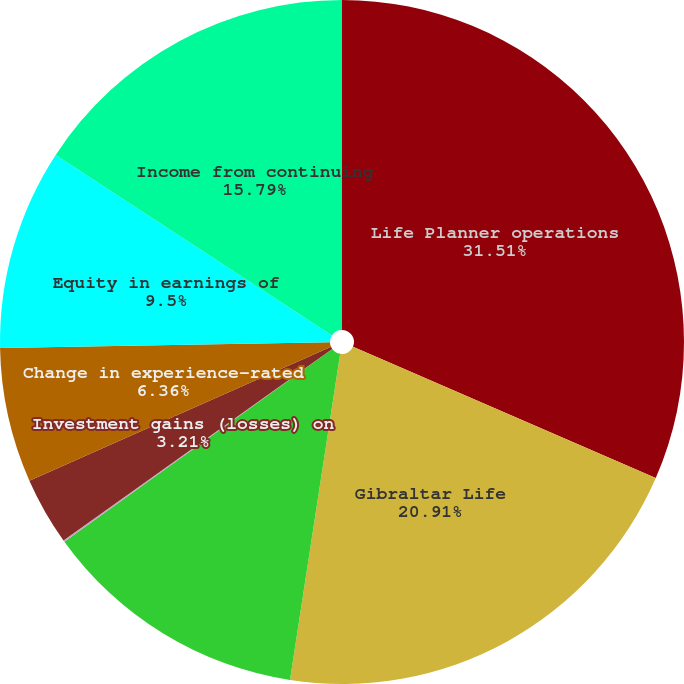Convert chart. <chart><loc_0><loc_0><loc_500><loc_500><pie_chart><fcel>Life Planner operations<fcel>Gibraltar Life<fcel>Realized investment gains<fcel>Related charges(2)<fcel>Investment gains (losses) on<fcel>Change in experience-rated<fcel>Equity in earnings of<fcel>Income from continuing<nl><fcel>31.52%<fcel>20.92%<fcel>12.65%<fcel>0.07%<fcel>3.21%<fcel>6.36%<fcel>9.5%<fcel>15.79%<nl></chart> 